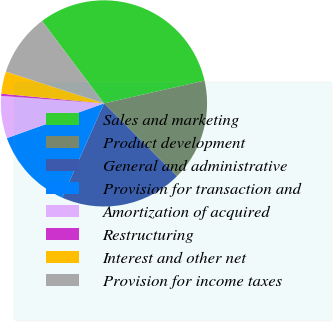Convert chart to OTSL. <chart><loc_0><loc_0><loc_500><loc_500><pie_chart><fcel>Sales and marketing<fcel>Product development<fcel>General and administrative<fcel>Provision for transaction and<fcel>Amortization of acquired<fcel>Restructuring<fcel>Interest and other net<fcel>Provision for income taxes<nl><fcel>31.71%<fcel>16.03%<fcel>19.16%<fcel>12.89%<fcel>6.62%<fcel>0.35%<fcel>3.48%<fcel>9.76%<nl></chart> 